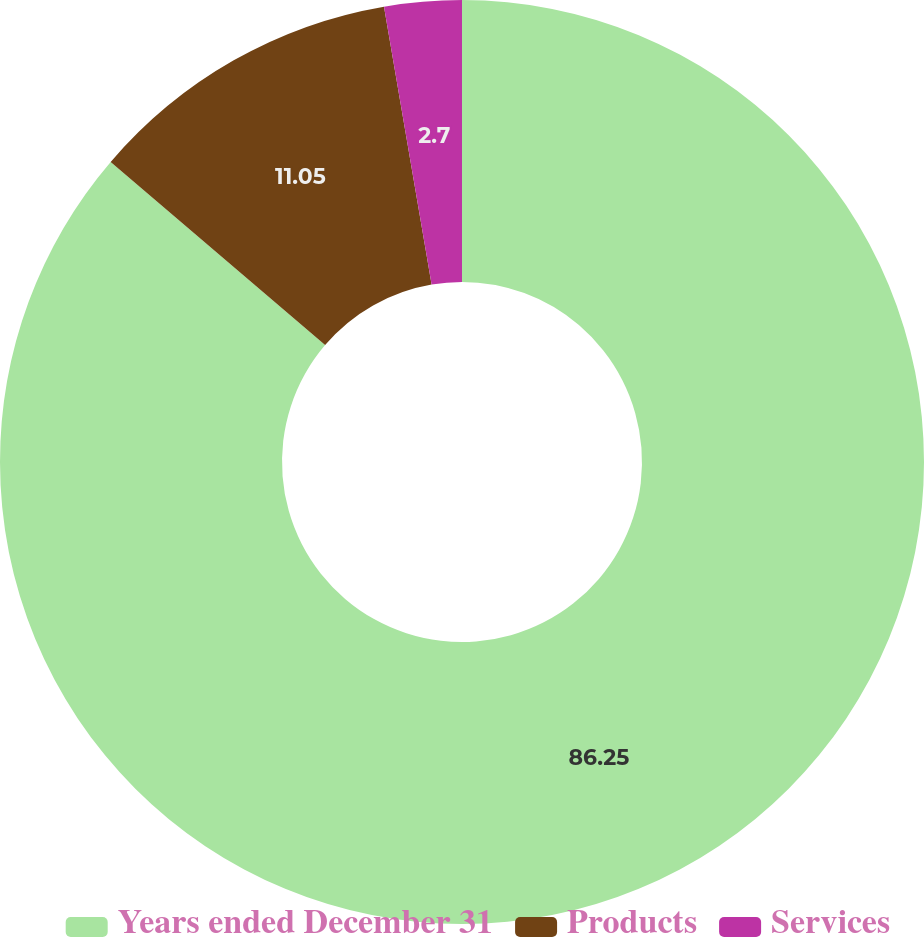Convert chart to OTSL. <chart><loc_0><loc_0><loc_500><loc_500><pie_chart><fcel>Years ended December 31<fcel>Products<fcel>Services<nl><fcel>86.24%<fcel>11.05%<fcel>2.7%<nl></chart> 